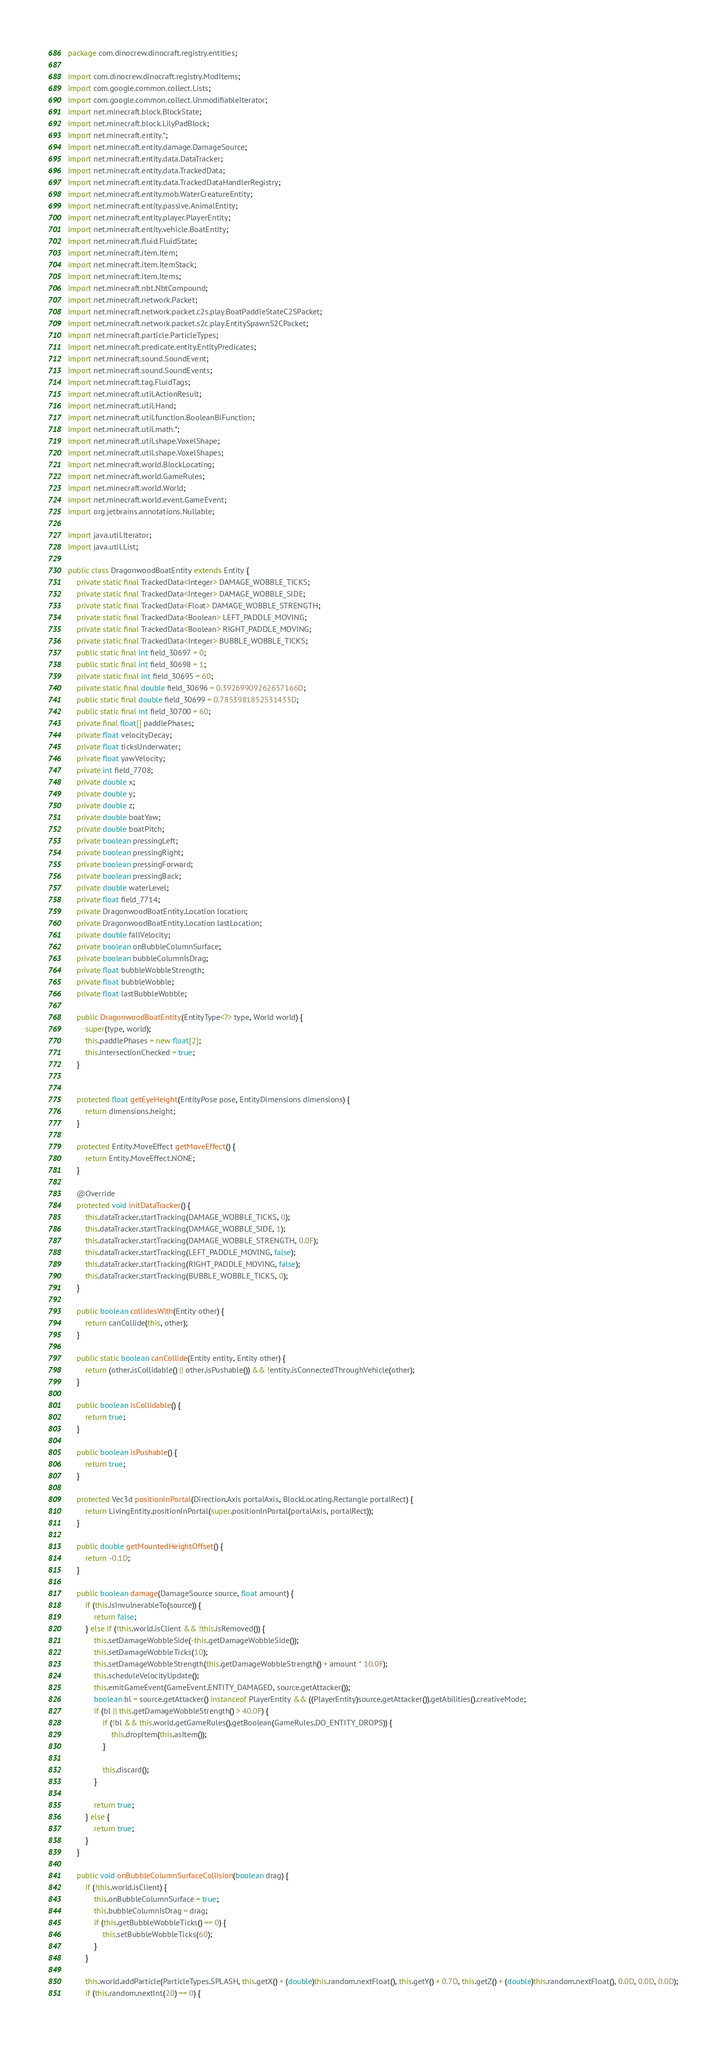<code> <loc_0><loc_0><loc_500><loc_500><_Java_>package com.dinocrew.dinocraft.registry.entities;

import com.dinocrew.dinocraft.registry.ModItems;
import com.google.common.collect.Lists;
import com.google.common.collect.UnmodifiableIterator;
import net.minecraft.block.BlockState;
import net.minecraft.block.LilyPadBlock;
import net.minecraft.entity.*;
import net.minecraft.entity.damage.DamageSource;
import net.minecraft.entity.data.DataTracker;
import net.minecraft.entity.data.TrackedData;
import net.minecraft.entity.data.TrackedDataHandlerRegistry;
import net.minecraft.entity.mob.WaterCreatureEntity;
import net.minecraft.entity.passive.AnimalEntity;
import net.minecraft.entity.player.PlayerEntity;
import net.minecraft.entity.vehicle.BoatEntity;
import net.minecraft.fluid.FluidState;
import net.minecraft.item.Item;
import net.minecraft.item.ItemStack;
import net.minecraft.item.Items;
import net.minecraft.nbt.NbtCompound;
import net.minecraft.network.Packet;
import net.minecraft.network.packet.c2s.play.BoatPaddleStateC2SPacket;
import net.minecraft.network.packet.s2c.play.EntitySpawnS2CPacket;
import net.minecraft.particle.ParticleTypes;
import net.minecraft.predicate.entity.EntityPredicates;
import net.minecraft.sound.SoundEvent;
import net.minecraft.sound.SoundEvents;
import net.minecraft.tag.FluidTags;
import net.minecraft.util.ActionResult;
import net.minecraft.util.Hand;
import net.minecraft.util.function.BooleanBiFunction;
import net.minecraft.util.math.*;
import net.minecraft.util.shape.VoxelShape;
import net.minecraft.util.shape.VoxelShapes;
import net.minecraft.world.BlockLocating;
import net.minecraft.world.GameRules;
import net.minecraft.world.World;
import net.minecraft.world.event.GameEvent;
import org.jetbrains.annotations.Nullable;

import java.util.Iterator;
import java.util.List;

public class DragonwoodBoatEntity extends Entity {
    private static final TrackedData<Integer> DAMAGE_WOBBLE_TICKS;
    private static final TrackedData<Integer> DAMAGE_WOBBLE_SIDE;
    private static final TrackedData<Float> DAMAGE_WOBBLE_STRENGTH;
    private static final TrackedData<Boolean> LEFT_PADDLE_MOVING;
    private static final TrackedData<Boolean> RIGHT_PADDLE_MOVING;
    private static final TrackedData<Integer> BUBBLE_WOBBLE_TICKS;
    public static final int field_30697 = 0;
    public static final int field_30698 = 1;
    private static final int field_30695 = 60;
    private static final double field_30696 = 0.39269909262657166D;
    public static final double field_30699 = 0.7853981852531433D;
    public static final int field_30700 = 60;
    private final float[] paddlePhases;
    private float velocityDecay;
    private float ticksUnderwater;
    private float yawVelocity;
    private int field_7708;
    private double x;
    private double y;
    private double z;
    private double boatYaw;
    private double boatPitch;
    private boolean pressingLeft;
    private boolean pressingRight;
    private boolean pressingForward;
    private boolean pressingBack;
    private double waterLevel;
    private float field_7714;
    private DragonwoodBoatEntity.Location location;
    private DragonwoodBoatEntity.Location lastLocation;
    private double fallVelocity;
    private boolean onBubbleColumnSurface;
    private boolean bubbleColumnIsDrag;
    private float bubbleWobbleStrength;
    private float bubbleWobble;
    private float lastBubbleWobble;

    public DragonwoodBoatEntity(EntityType<?> type, World world) {
        super(type, world);
        this.paddlePhases = new float[2];
        this.intersectionChecked = true;
    }


    protected float getEyeHeight(EntityPose pose, EntityDimensions dimensions) {
        return dimensions.height;
    }

    protected Entity.MoveEffect getMoveEffect() {
        return Entity.MoveEffect.NONE;
    }

    @Override
    protected void initDataTracker() {
        this.dataTracker.startTracking(DAMAGE_WOBBLE_TICKS, 0);
        this.dataTracker.startTracking(DAMAGE_WOBBLE_SIDE, 1);
        this.dataTracker.startTracking(DAMAGE_WOBBLE_STRENGTH, 0.0F);
        this.dataTracker.startTracking(LEFT_PADDLE_MOVING, false);
        this.dataTracker.startTracking(RIGHT_PADDLE_MOVING, false);
        this.dataTracker.startTracking(BUBBLE_WOBBLE_TICKS, 0);
    }

    public boolean collidesWith(Entity other) {
        return canCollide(this, other);
    }

    public static boolean canCollide(Entity entity, Entity other) {
        return (other.isCollidable() || other.isPushable()) && !entity.isConnectedThroughVehicle(other);
    }

    public boolean isCollidable() {
        return true;
    }

    public boolean isPushable() {
        return true;
    }

    protected Vec3d positionInPortal(Direction.Axis portalAxis, BlockLocating.Rectangle portalRect) {
        return LivingEntity.positionInPortal(super.positionInPortal(portalAxis, portalRect));
    }

    public double getMountedHeightOffset() {
        return -0.1D;
    }

    public boolean damage(DamageSource source, float amount) {
        if (this.isInvulnerableTo(source)) {
            return false;
        } else if (!this.world.isClient && !this.isRemoved()) {
            this.setDamageWobbleSide(-this.getDamageWobbleSide());
            this.setDamageWobbleTicks(10);
            this.setDamageWobbleStrength(this.getDamageWobbleStrength() + amount * 10.0F);
            this.scheduleVelocityUpdate();
            this.emitGameEvent(GameEvent.ENTITY_DAMAGED, source.getAttacker());
            boolean bl = source.getAttacker() instanceof PlayerEntity && ((PlayerEntity)source.getAttacker()).getAbilities().creativeMode;
            if (bl || this.getDamageWobbleStrength() > 40.0F) {
                if (!bl && this.world.getGameRules().getBoolean(GameRules.DO_ENTITY_DROPS)) {
                    this.dropItem(this.asItem());
                }

                this.discard();
            }

            return true;
        } else {
            return true;
        }
    }

    public void onBubbleColumnSurfaceCollision(boolean drag) {
        if (!this.world.isClient) {
            this.onBubbleColumnSurface = true;
            this.bubbleColumnIsDrag = drag;
            if (this.getBubbleWobbleTicks() == 0) {
                this.setBubbleWobbleTicks(60);
            }
        }

        this.world.addParticle(ParticleTypes.SPLASH, this.getX() + (double)this.random.nextFloat(), this.getY() + 0.7D, this.getZ() + (double)this.random.nextFloat(), 0.0D, 0.0D, 0.0D);
        if (this.random.nextInt(20) == 0) {</code> 